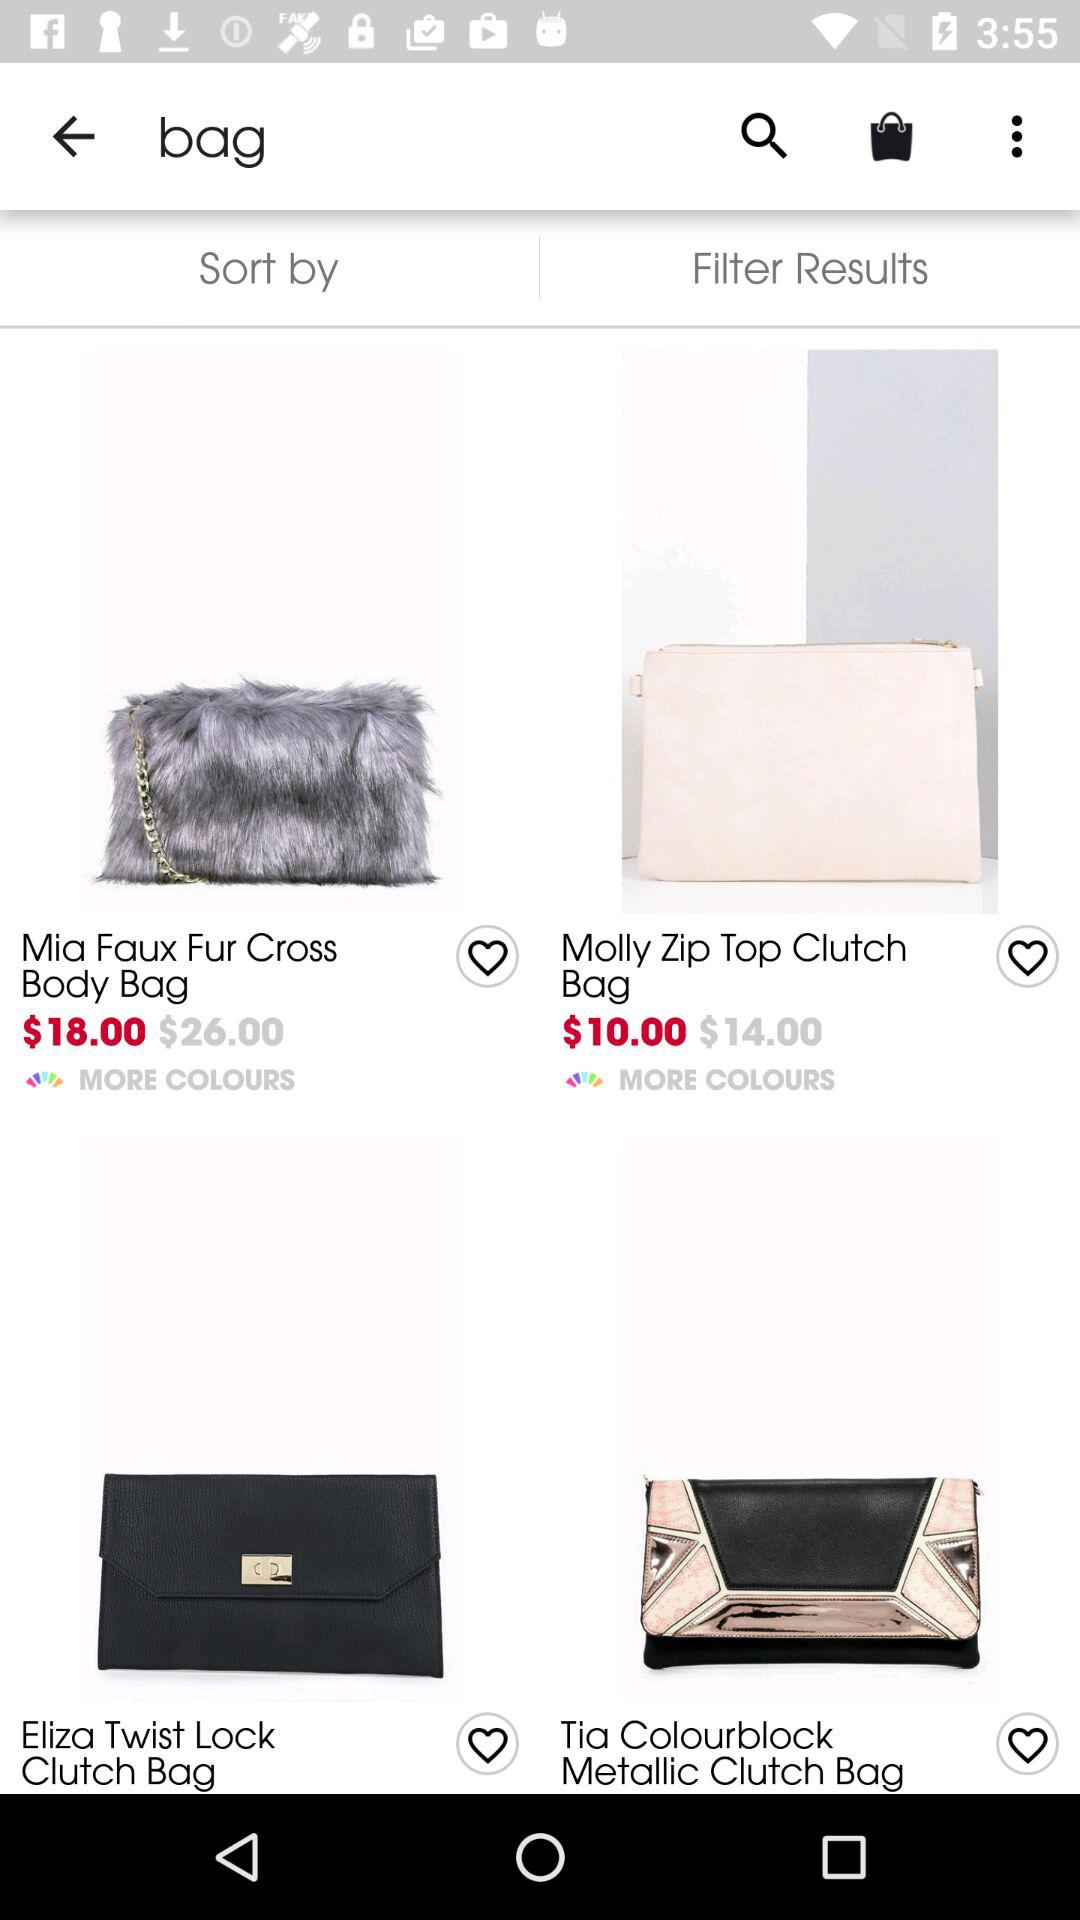What is the price of the "Mia Faux Fur Cross Body Bag" after discount? The price is $18.00. 